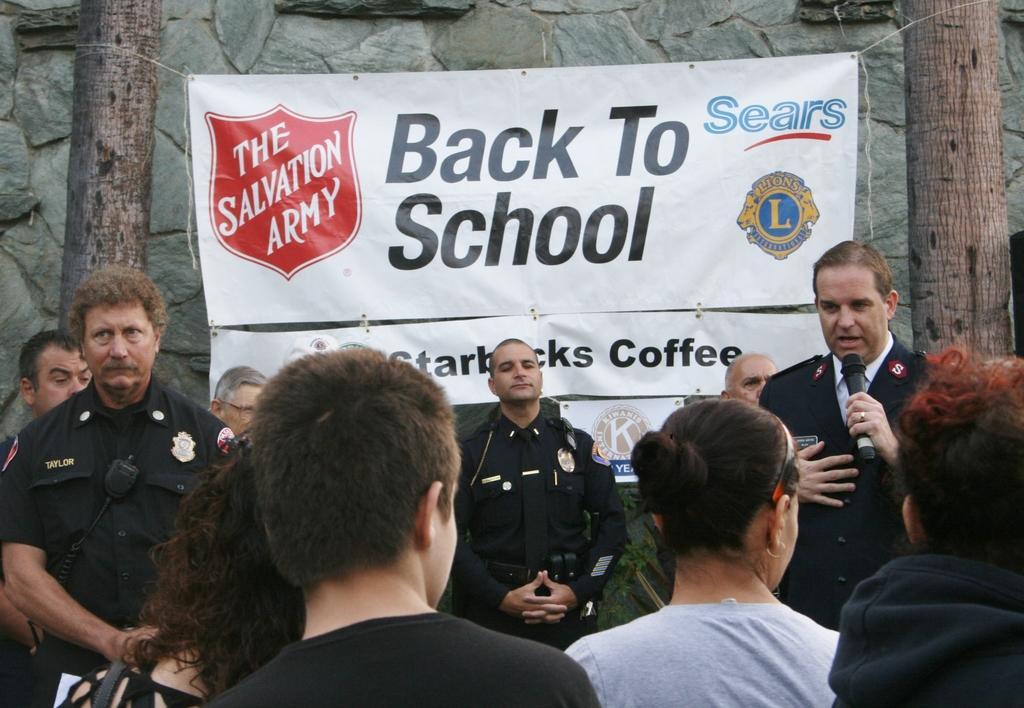Describe this image in one or two sentences. In this picture there are group of people, among them there's a man holding a microphone. In the background of the image we can see banner, tree trunks and the wall. 